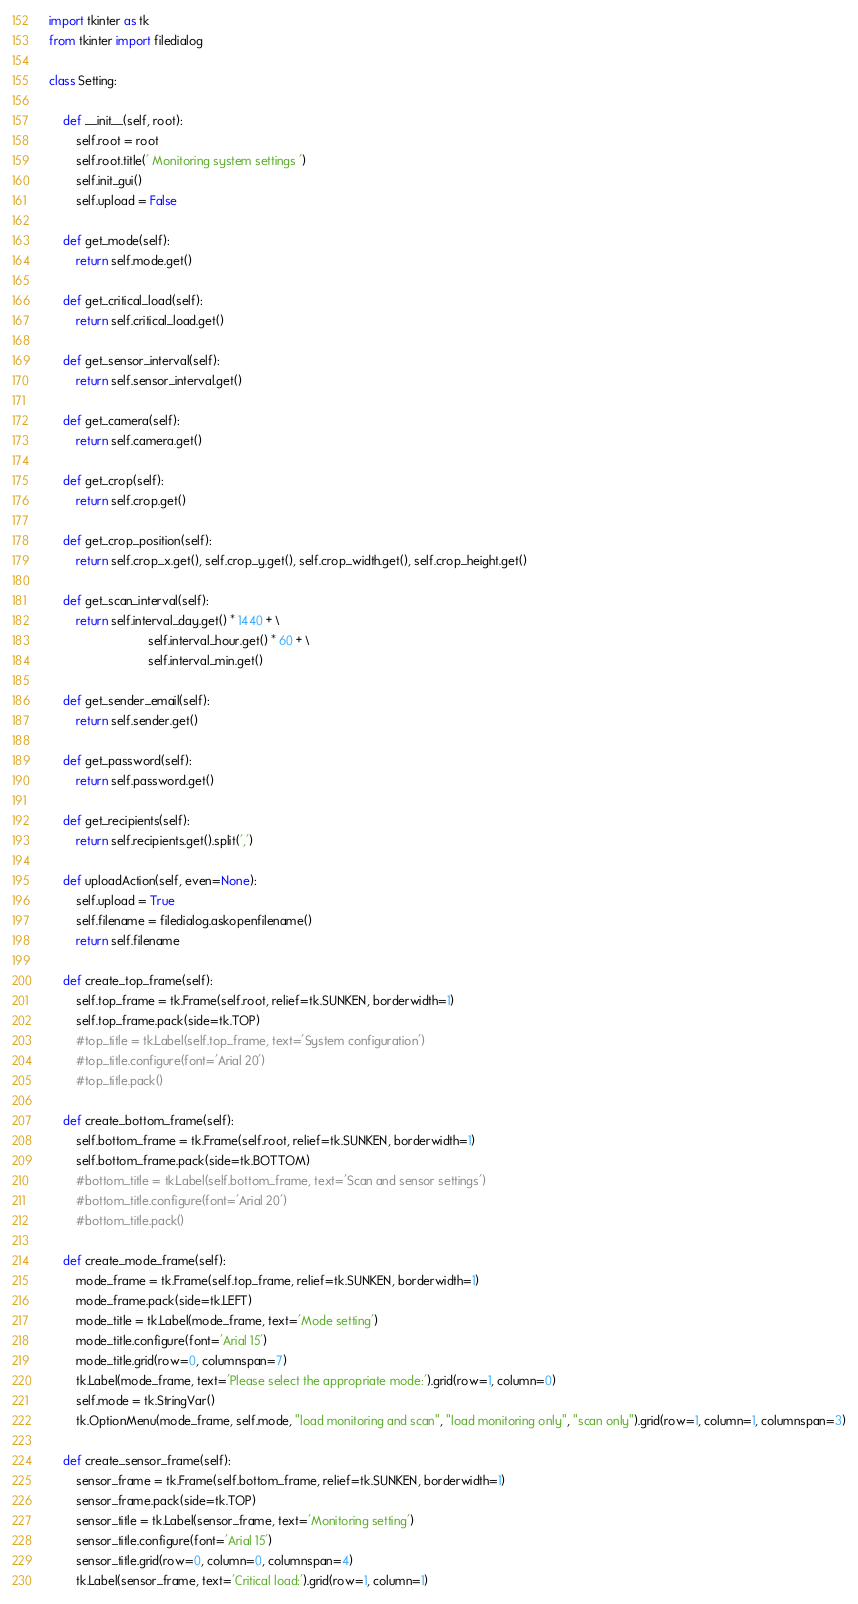Convert code to text. <code><loc_0><loc_0><loc_500><loc_500><_Python_>import tkinter as tk
from tkinter import filedialog

class Setting:

    def __init__(self, root):
        self.root = root
        self.root.title(' Monitoring system settings ')
        self.init_gui()
        self.upload = False
    
    def get_mode(self):
        return self.mode.get()
    
    def get_critical_load(self):
        return self.critical_load.get()
    
    def get_sensor_interval(self):
        return self.sensor_interval.get()
    
    def get_camera(self):
        return self.camera.get()
    
    def get_crop(self):
        return self.crop.get()
    
    def get_crop_position(self):
        return self.crop_x.get(), self.crop_y.get(), self.crop_width.get(), self.crop_height.get()
    
    def get_scan_interval(self):
        return self.interval_day.get() * 1440 + \
                             self.interval_hour.get() * 60 + \
                             self.interval_min.get()
    
    def get_sender_email(self):
        return self.sender.get()
    
    def get_password(self):
        return self.password.get()
    
    def get_recipients(self):
        return self.recipients.get().split(',')
    
    def uploadAction(self, even=None):
        self.upload = True
        self.filename = filedialog.askopenfilename()
        return self.filename
    
    def create_top_frame(self):
        self.top_frame = tk.Frame(self.root, relief=tk.SUNKEN, borderwidth=1)
        self.top_frame.pack(side=tk.TOP)
        #top_title = tk.Label(self.top_frame, text='System configuration')
        #top_title.configure(font='Arial 20')
        #top_title.pack()
        
    def create_bottom_frame(self):
        self.bottom_frame = tk.Frame(self.root, relief=tk.SUNKEN, borderwidth=1)
        self.bottom_frame.pack(side=tk.BOTTOM)
        #bottom_title = tk.Label(self.bottom_frame, text='Scan and sensor settings')
        #bottom_title.configure(font='Arial 20')
        #bottom_title.pack()
        
    def create_mode_frame(self):
        mode_frame = tk.Frame(self.top_frame, relief=tk.SUNKEN, borderwidth=1)
        mode_frame.pack(side=tk.LEFT)
        mode_title = tk.Label(mode_frame, text='Mode setting')
        mode_title.configure(font='Arial 15')
        mode_title.grid(row=0, columnspan=7)
        tk.Label(mode_frame, text='Please select the appropriate mode:').grid(row=1, column=0)
        self.mode = tk.StringVar()
        tk.OptionMenu(mode_frame, self.mode, "load monitoring and scan", "load monitoring only", "scan only").grid(row=1, column=1, columnspan=3)
        
    def create_sensor_frame(self):
        sensor_frame = tk.Frame(self.bottom_frame, relief=tk.SUNKEN, borderwidth=1)
        sensor_frame.pack(side=tk.TOP)
        sensor_title = tk.Label(sensor_frame, text='Monitoring setting')
        sensor_title.configure(font='Arial 15')
        sensor_title.grid(row=0, column=0, columnspan=4)
        tk.Label(sensor_frame, text='Critical load:').grid(row=1, column=1)</code> 